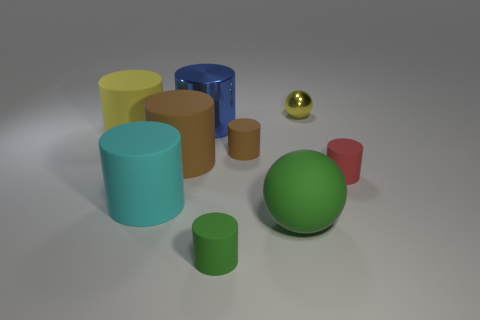Subtract 2 cylinders. How many cylinders are left? 5 Subtract all blue cylinders. How many cylinders are left? 6 Subtract all large yellow cylinders. How many cylinders are left? 6 Subtract all red cylinders. Subtract all green cubes. How many cylinders are left? 6 Subtract all cylinders. How many objects are left? 2 Add 6 tiny yellow metallic balls. How many tiny yellow metallic balls are left? 7 Add 1 yellow cylinders. How many yellow cylinders exist? 2 Subtract 0 brown cubes. How many objects are left? 9 Subtract all brown things. Subtract all large blue metallic objects. How many objects are left? 6 